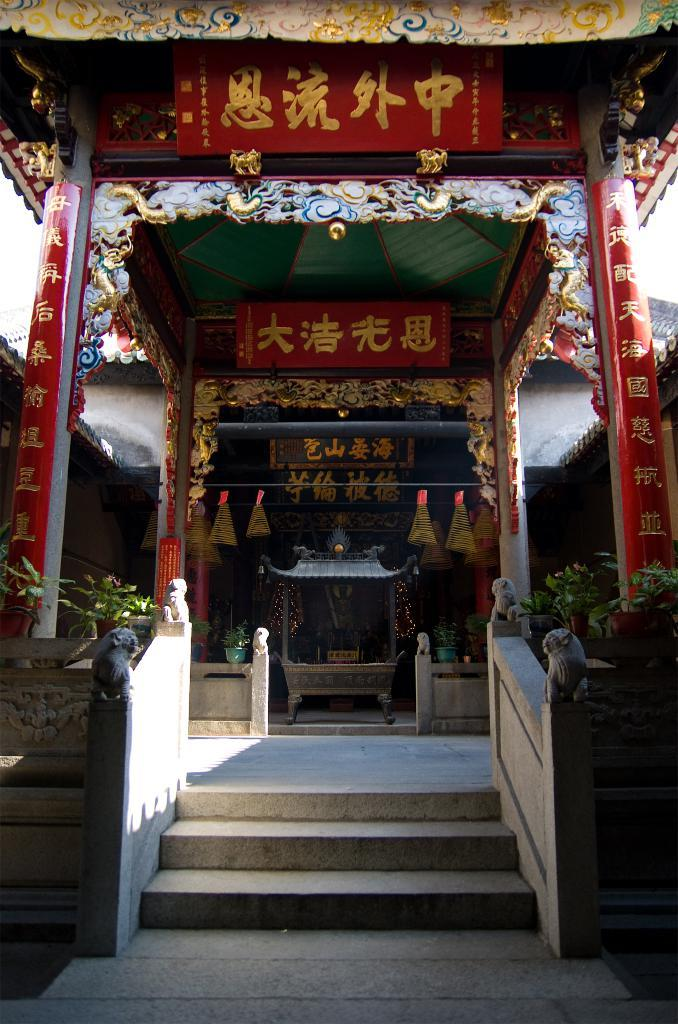What is the main feature of the canopy in the image? The canopy in the image is made with glitters. What is located under the canopy? There is a sculpture under the canopy. Where are the plants situated in the image? The plants are beside the stairs in the image. What is the temperature of the mine in the image? There is no mine present in the image, so it is not possible to determine the temperature. How does the sculpture express its feelings of hate in the image? The sculpture does not express any feelings, as it is an inanimate object. 